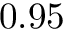Convert formula to latex. <formula><loc_0><loc_0><loc_500><loc_500>0 . 9 5</formula> 